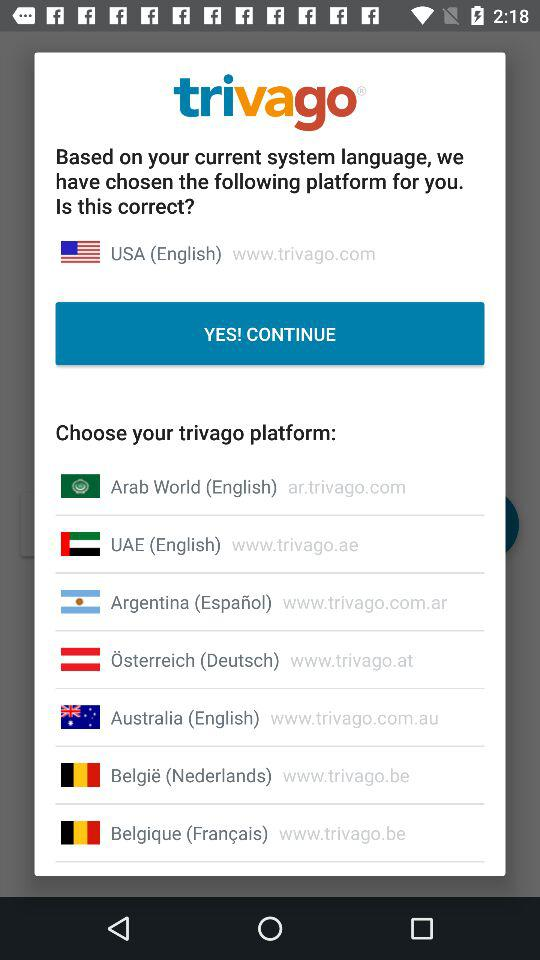What is the application name? The application name is "trivago". 